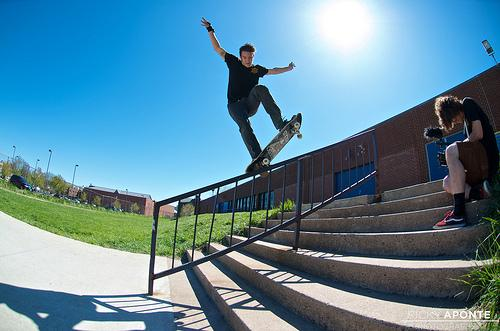Elaborate the core event occurring in the image and include information about notable features. A talented skateboarder is seen grinding on a railing, as other people, including someone sitting on the stairs, observe the scene. Describe the major elements and the primary action in the image. The image features a teenager skateboarding, grinding on a railing under a blue sky with a bright sun, near a school with blue doors. What is the main subject performing and how does the environment add to the scene? A man is executing a skateboarding trick down a railing, with the surrounding clear blue sky adding brightness to the scene. Write a brief description of the primary activity happening in the image, also mentioning any buildings. A person slides down a rail on a skateboard, with a brick building in the background and blue doors nearby. What is the central figure in the image doing, including details about their equipment? A man sporting a bracelet and a tattoo on his arm is skateboarding down a railing, using a black and white skateboard. Report the primary action and surrounding atmosphere in the image. A skateboarder exhibits skill while performing a trick on a railing, as onlookers watch in the daytime setting. Describe the main character and their action in the image, including the surrounding environment. A skateboarder with his two arms raised grinds on a railing under a blue sky, with a clear view of vehicles in a parking lot. Express the central theme of the image, making note of the weather conditions. A skateboarder performs a daring trick during a bright, sunny day with a clear blue sky above him. Summarize the main activity portrayed in the image. A skateboarder is performing a trick, grinding down a railing, while his shadow can be seen on the ground. Mention the weather and the primary objects found in the scene. On a clear, sunny day, a person slides down a rail while skateboarders watch, and a bright sun radiates above. 